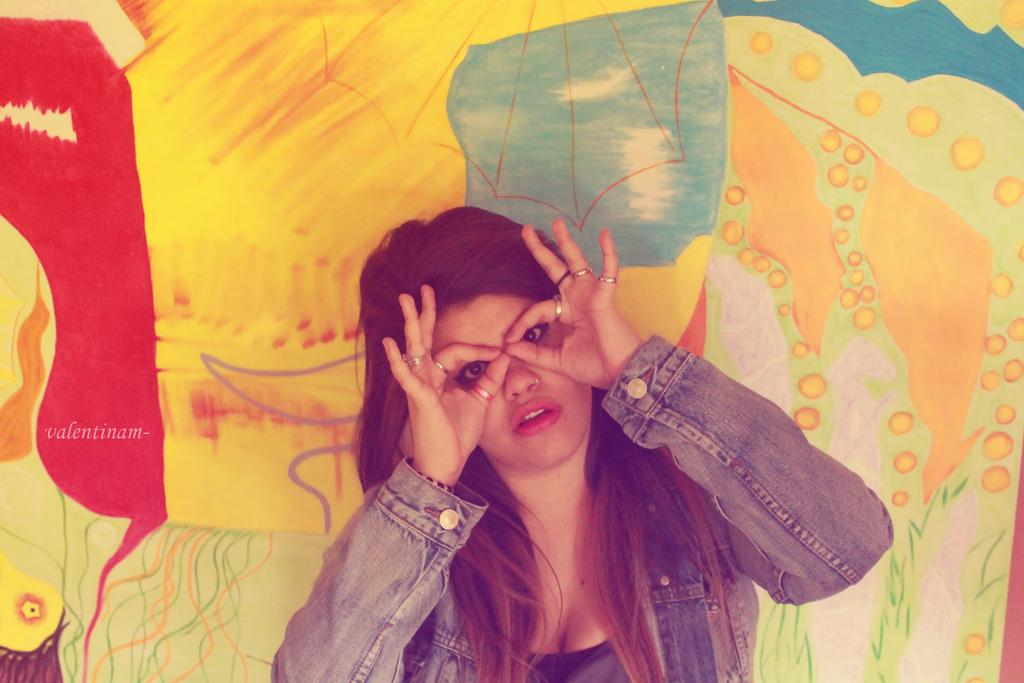Who is present in the image? There is a woman in the image. What can be seen in the background of the image? There is a painting in the background of the image. What type of game is the woman playing in the image? There is no game or play depicted in the image; it only features a woman and a painting in the background. 